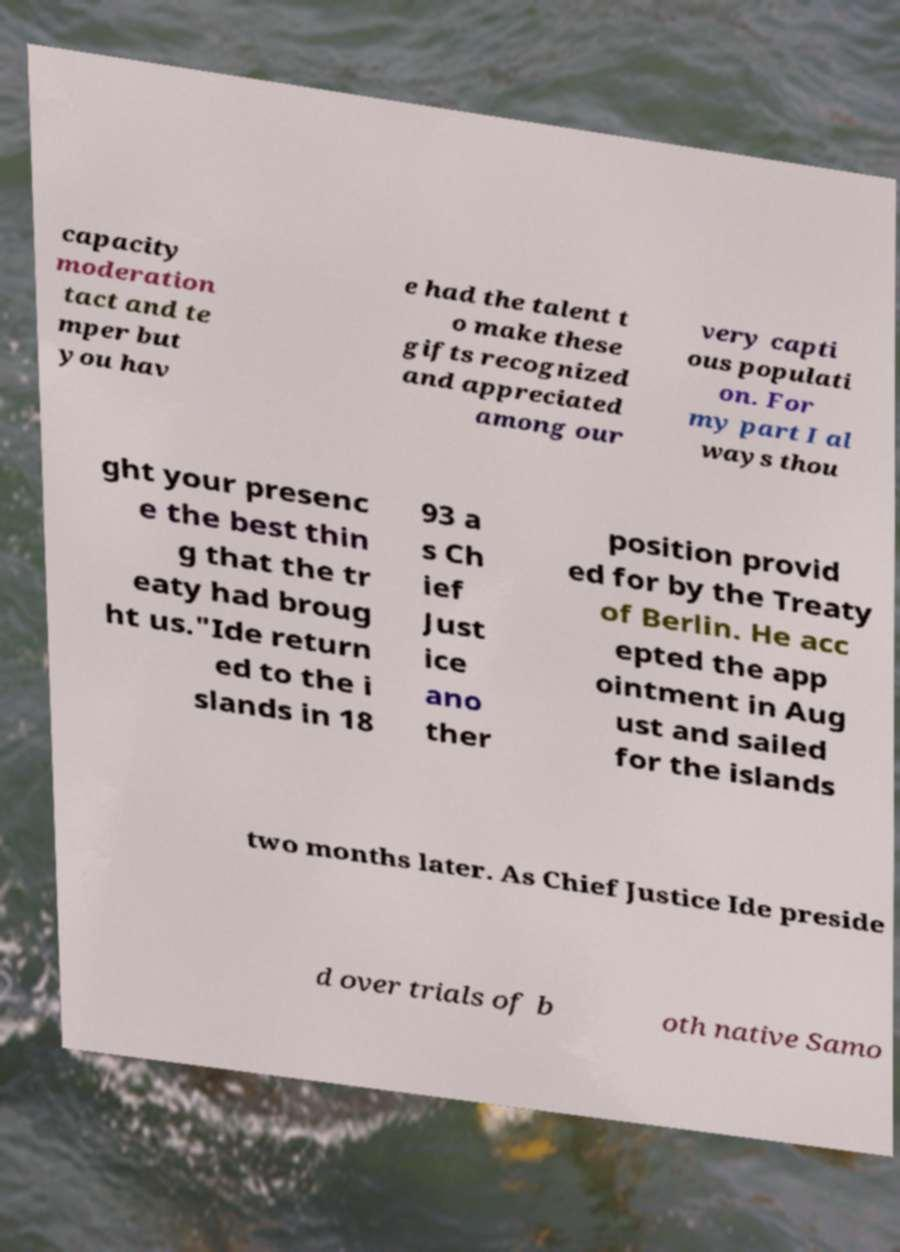What messages or text are displayed in this image? I need them in a readable, typed format. capacity moderation tact and te mper but you hav e had the talent t o make these gifts recognized and appreciated among our very capti ous populati on. For my part I al ways thou ght your presenc e the best thin g that the tr eaty had broug ht us."Ide return ed to the i slands in 18 93 a s Ch ief Just ice ano ther position provid ed for by the Treaty of Berlin. He acc epted the app ointment in Aug ust and sailed for the islands two months later. As Chief Justice Ide preside d over trials of b oth native Samo 